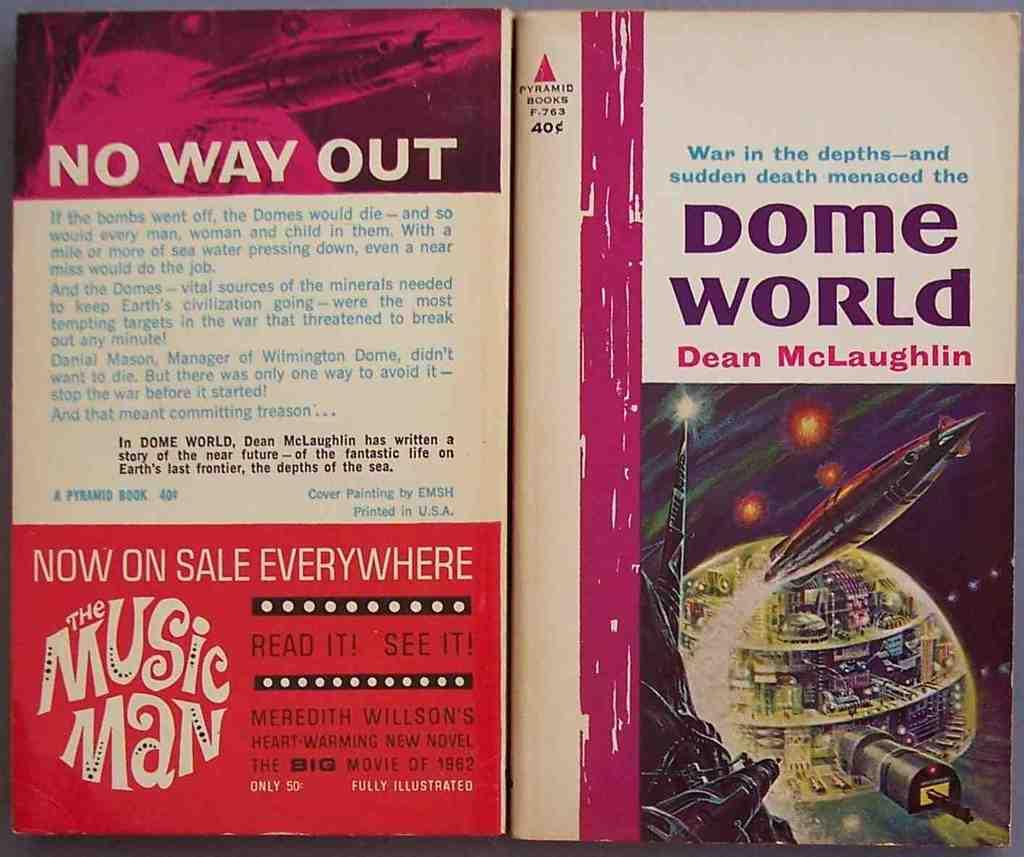<image>
Offer a succinct explanation of the picture presented. a book titled 'dome world' by dean mcluaghlin 